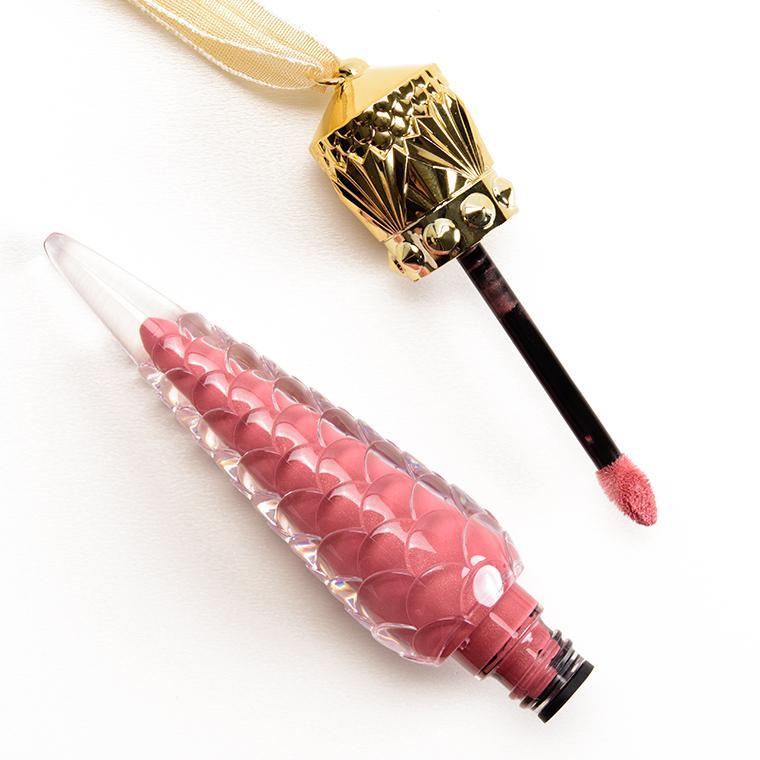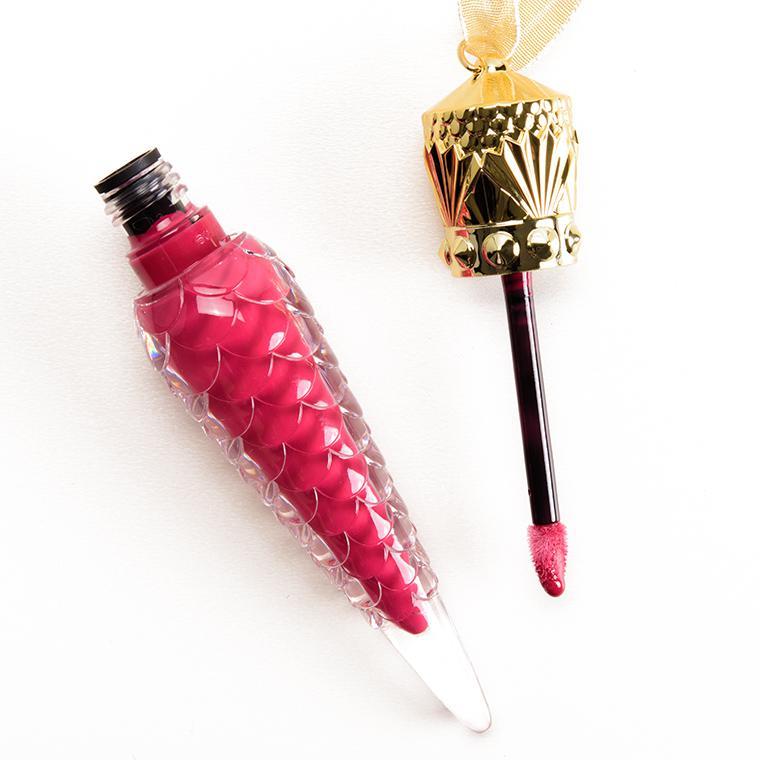The first image is the image on the left, the second image is the image on the right. Analyze the images presented: Is the assertion "An image shows at least eight ornament-shaped lipsticks in various shades." valid? Answer yes or no. No. The first image is the image on the left, the second image is the image on the right. For the images shown, is this caption "There are at least five cone shaped lipstick containers in the image on the left." true? Answer yes or no. No. 